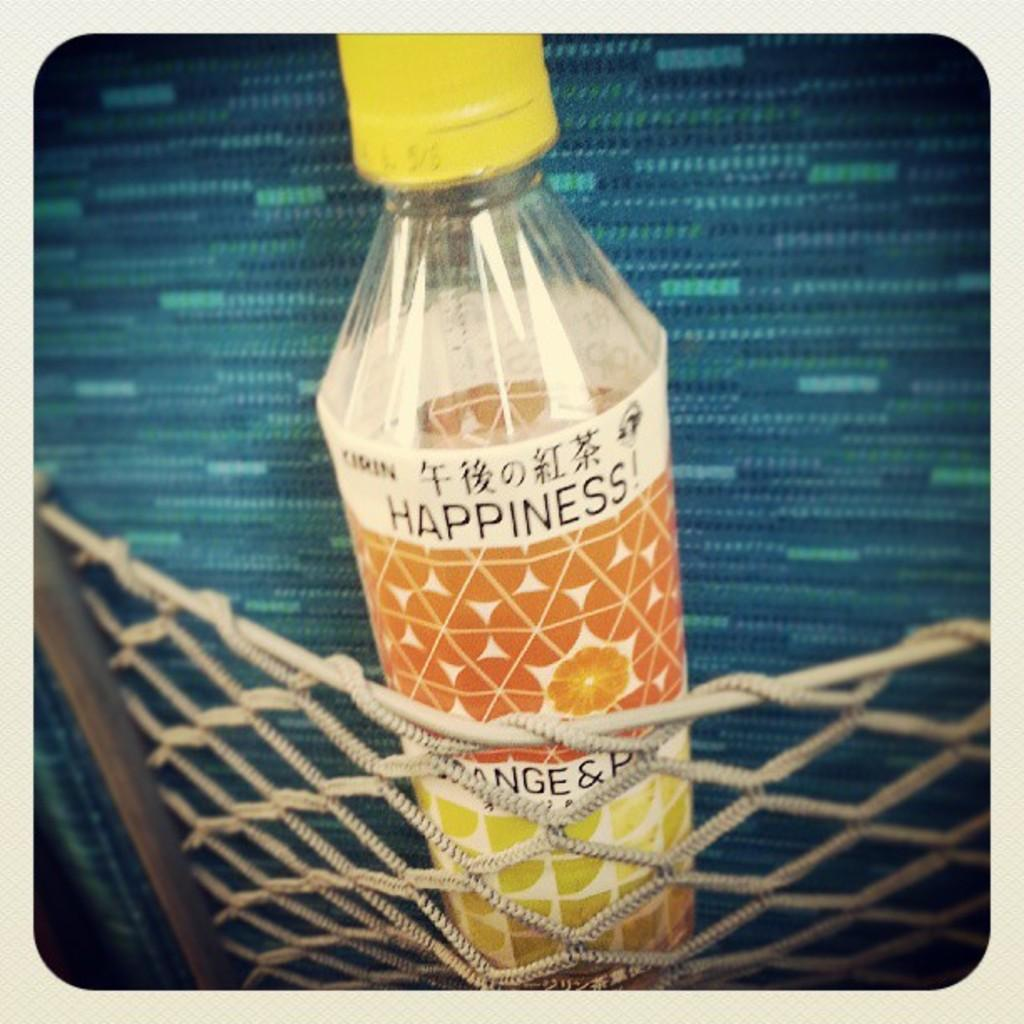Provide a one-sentence caption for the provided image. A bottle with a yellow top has the word happiness written on it. 